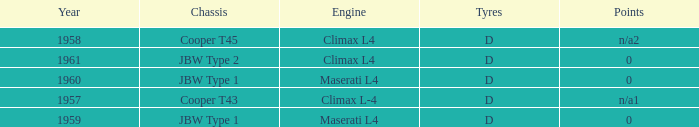What is the tyres for the JBW type 2 chassis? D. 